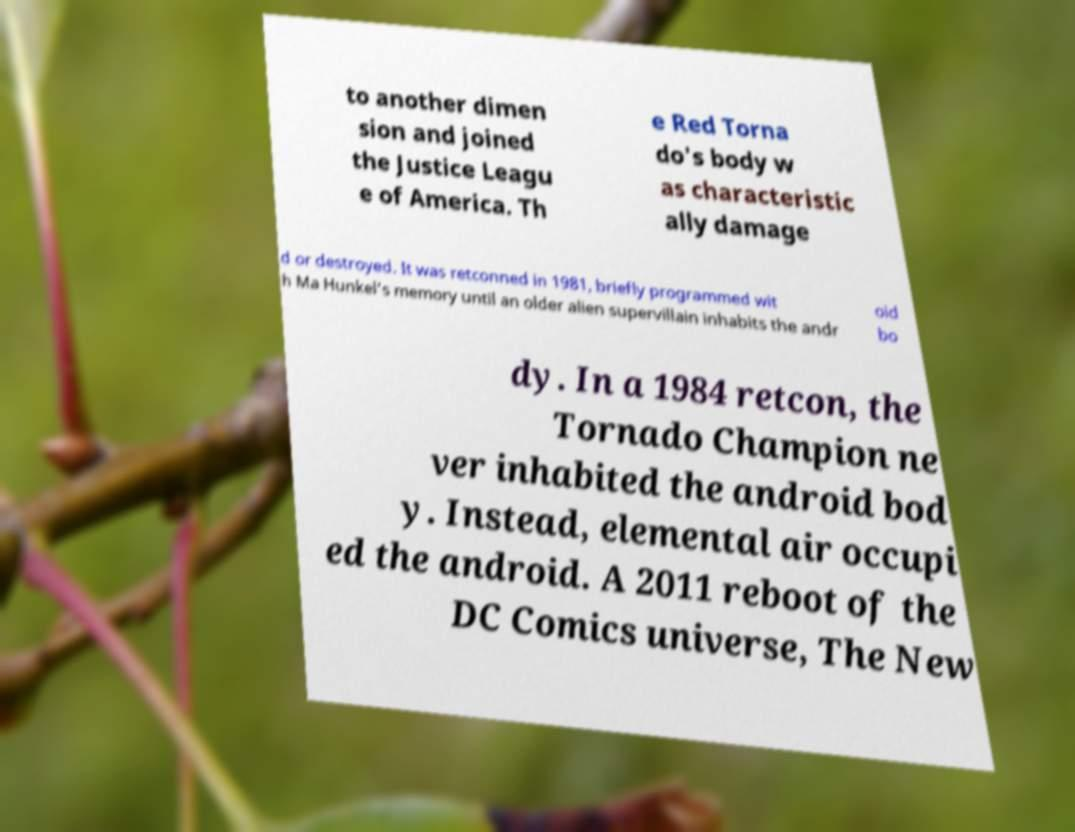Please read and relay the text visible in this image. What does it say? to another dimen sion and joined the Justice Leagu e of America. Th e Red Torna do's body w as characteristic ally damage d or destroyed. It was retconned in 1981, briefly programmed wit h Ma Hunkel's memory until an older alien supervillain inhabits the andr oid bo dy. In a 1984 retcon, the Tornado Champion ne ver inhabited the android bod y. Instead, elemental air occupi ed the android. A 2011 reboot of the DC Comics universe, The New 